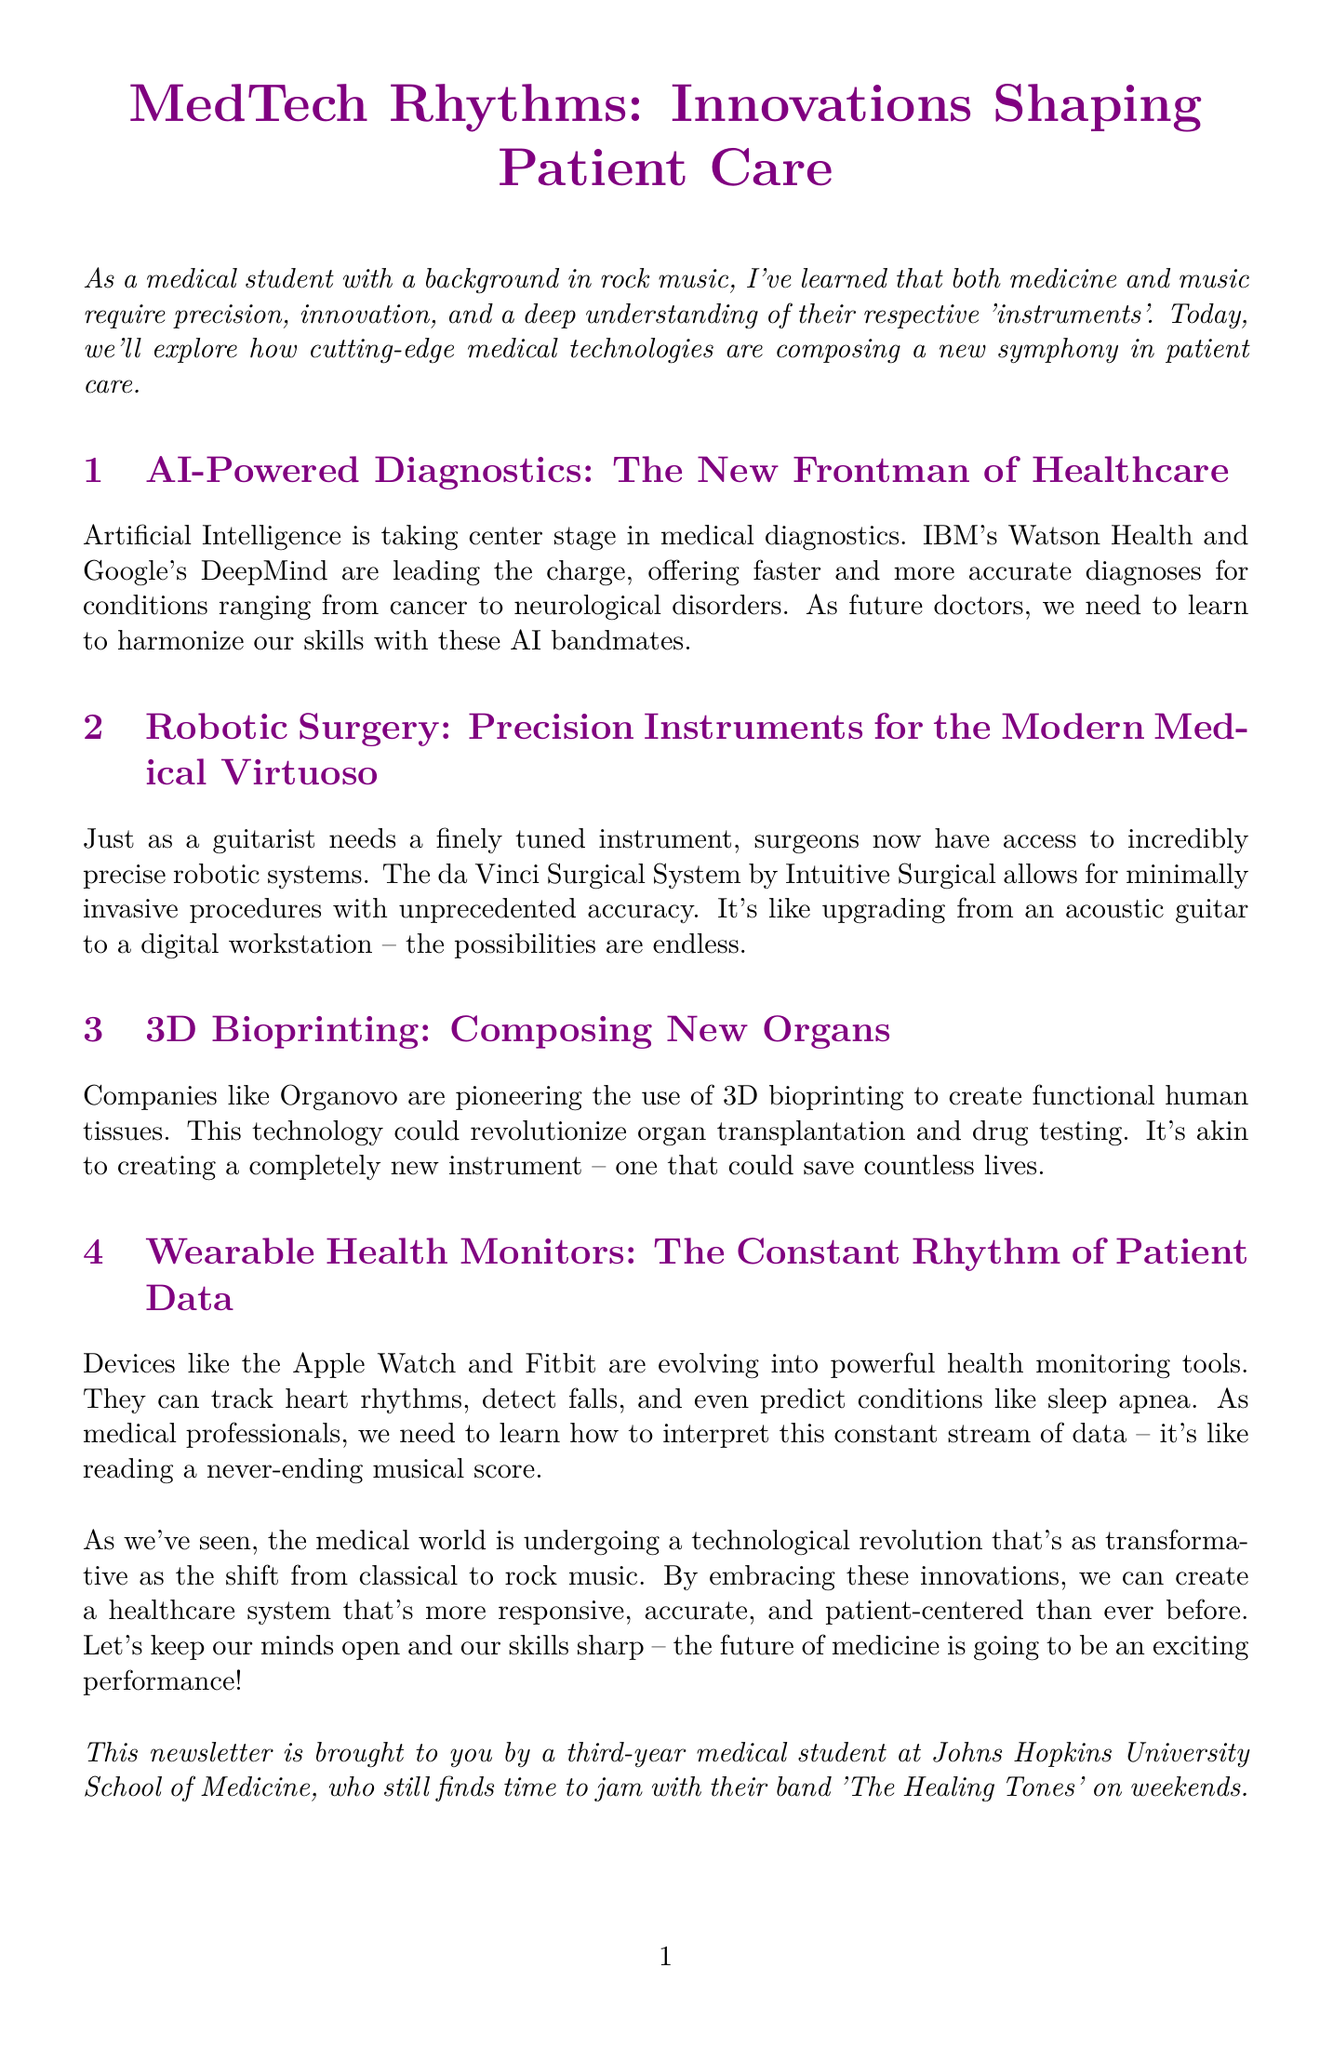What is the title of the newsletter? The title is given in the header of the document.
Answer: MedTech Rhythms: Innovations Shaping Patient Care Who is the author of the newsletter? The author's identity is mentioned in the conclusion.
Answer: a third-year medical student at Johns Hopkins University School of Medicine Which AI companies are mentioned in the diagnostics section? The document lists AI companies involved in diagnostics in this section.
Answer: IBM's Watson Health and Google's DeepMind What innovative surgical system is described in the newsletter? The newsletter specifically names a robotic surgery system in its content.
Answer: da Vinci Surgical System What is the main application of 3D bioprinting according to the document? The document highlights the purpose of 3D bioprinting in the main content section.
Answer: creating functional human tissues How do wearable health monitors help patients? The newsletter describes capabilities of wearable devices in tracking health.
Answer: track heart rhythms, detect falls, and predict conditions What metaphor does the author use to compare robotic surgery to musical instruments? The comparison in the document relates surgical precision to a type of musical instrument.
Answer: upgrading from an acoustic guitar to a digital workstation What is the impact of the technological revolution in healthcare according to the conclusion? The conclusion summarizes the transformative effect of medical technology.
Answer: more responsive, accurate, and patient-centered 